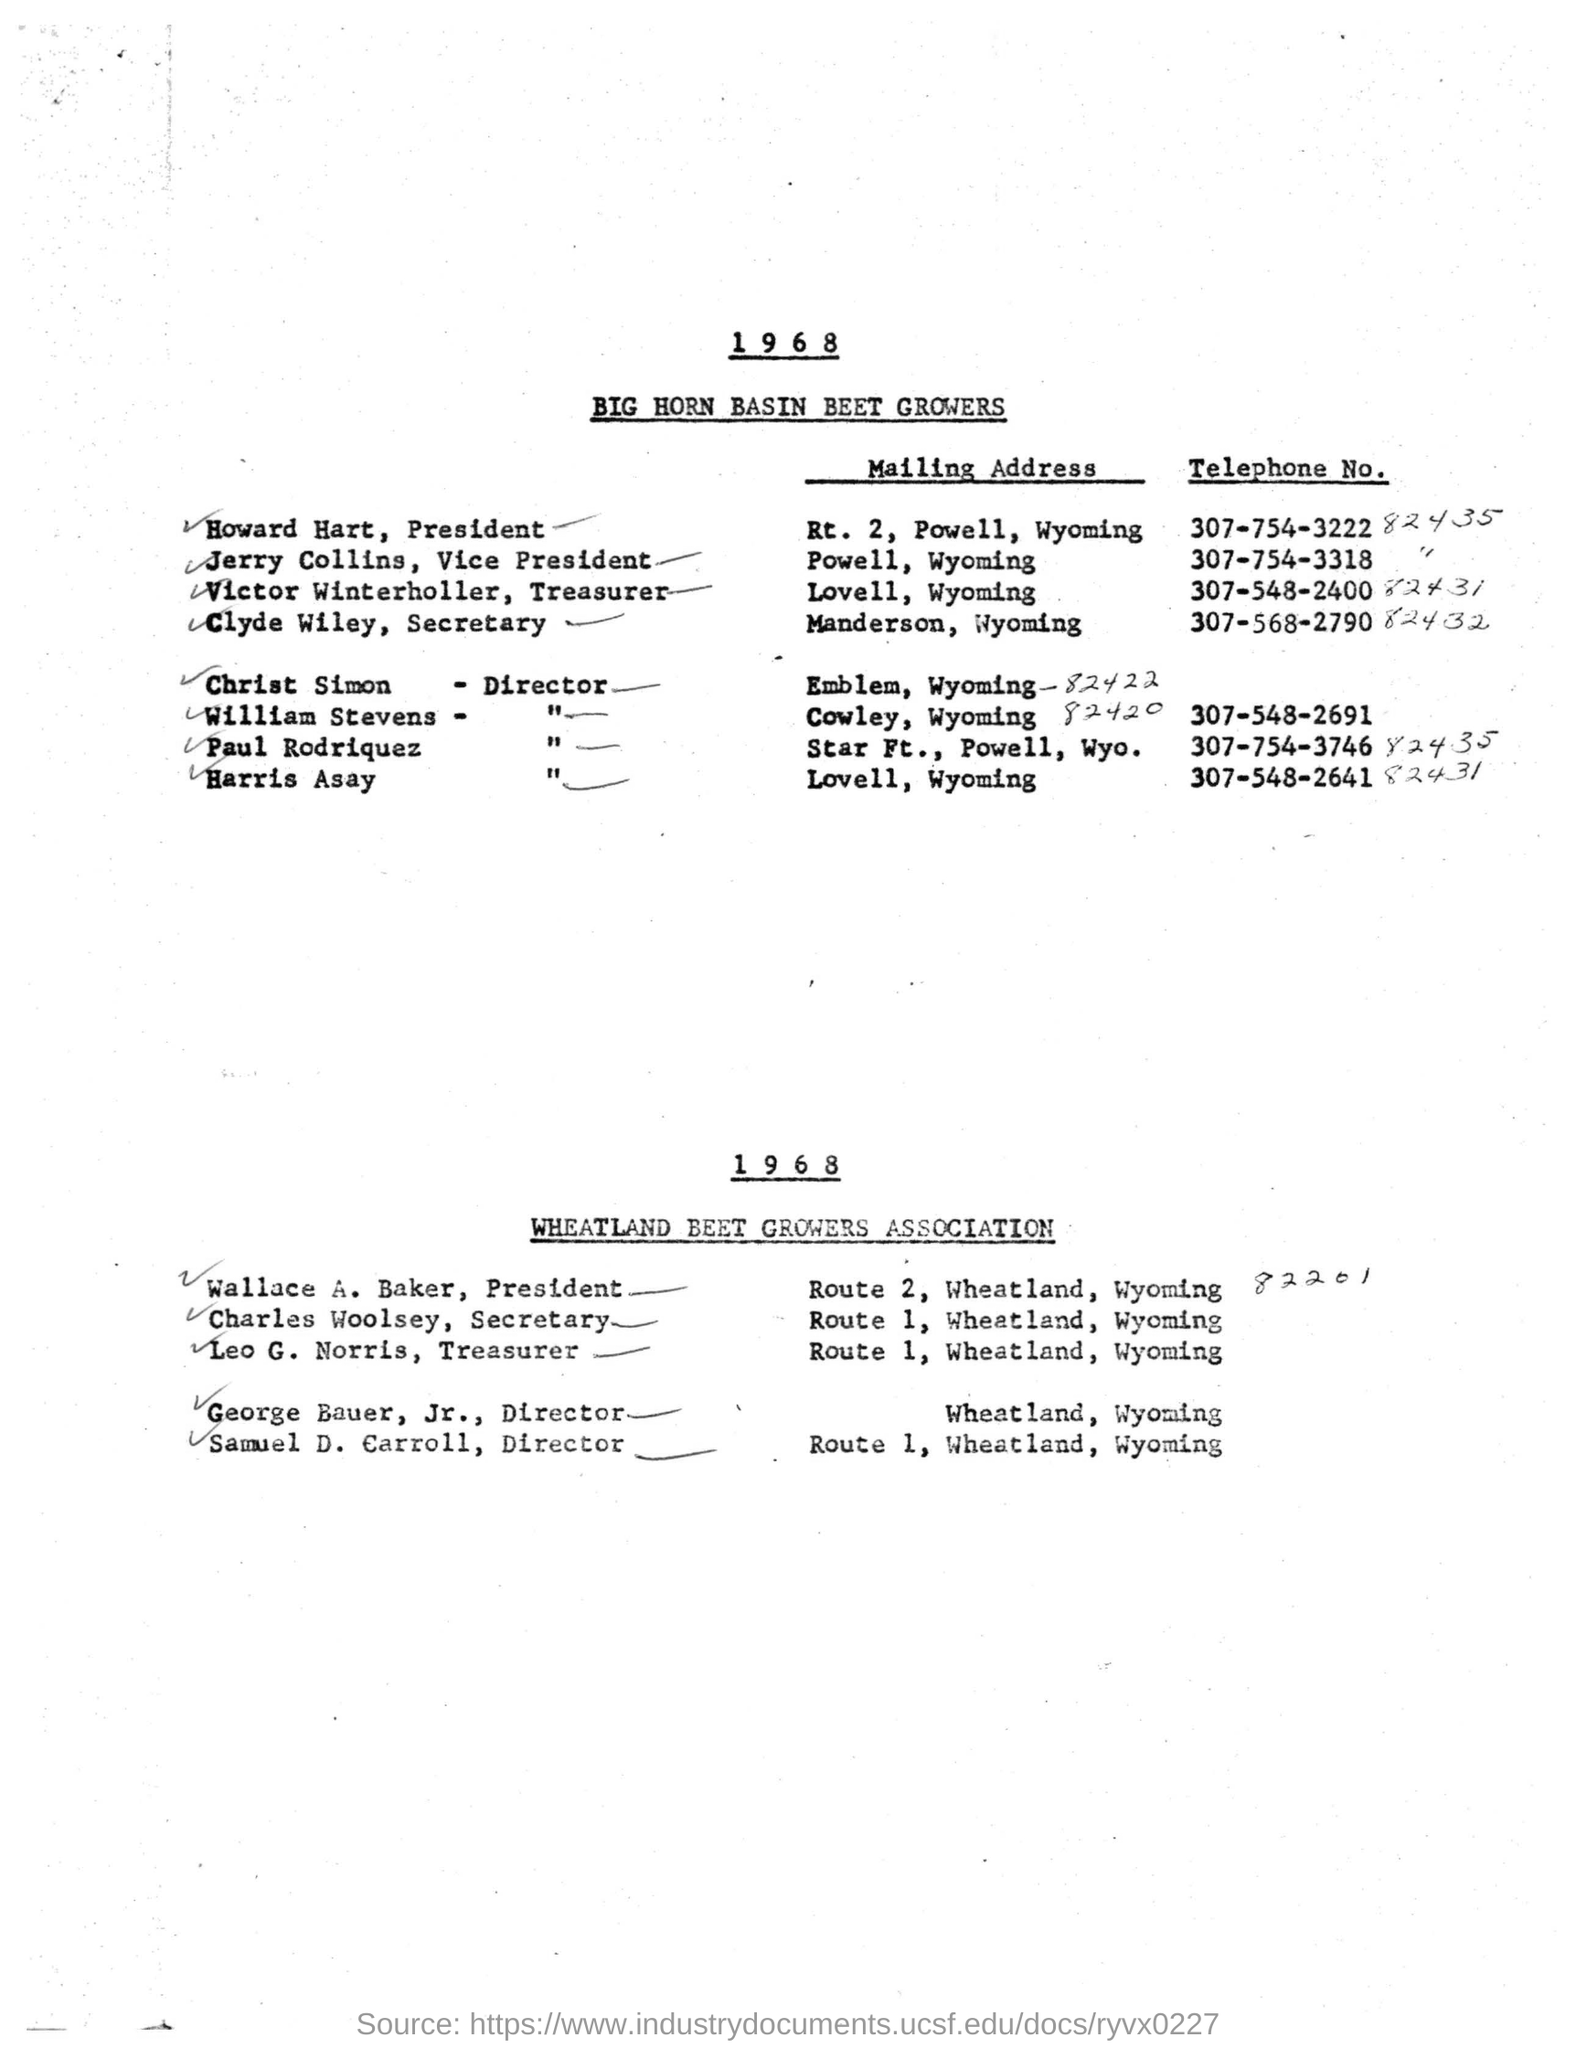What is the name of the growers?
Provide a succinct answer. BIG HORN BASIN BEET GROWERS. What is the mailing address of howard hart, president?
Make the answer very short. Rt. 2, Powell, Wyoming. What is the telephone no of clyde wiley, secretary?
Give a very brief answer. 307-568-2790 82432. Who is the president of wheatland beet growers association ?
Ensure brevity in your answer.  Wallace A. Baker. What is the mailing address for leo G.norris ?
Keep it short and to the point. Route 1, Wheatland, Wyoming. Who is the secretary of wheatland beet growers association ?
Offer a terse response. Charles woolsey. 